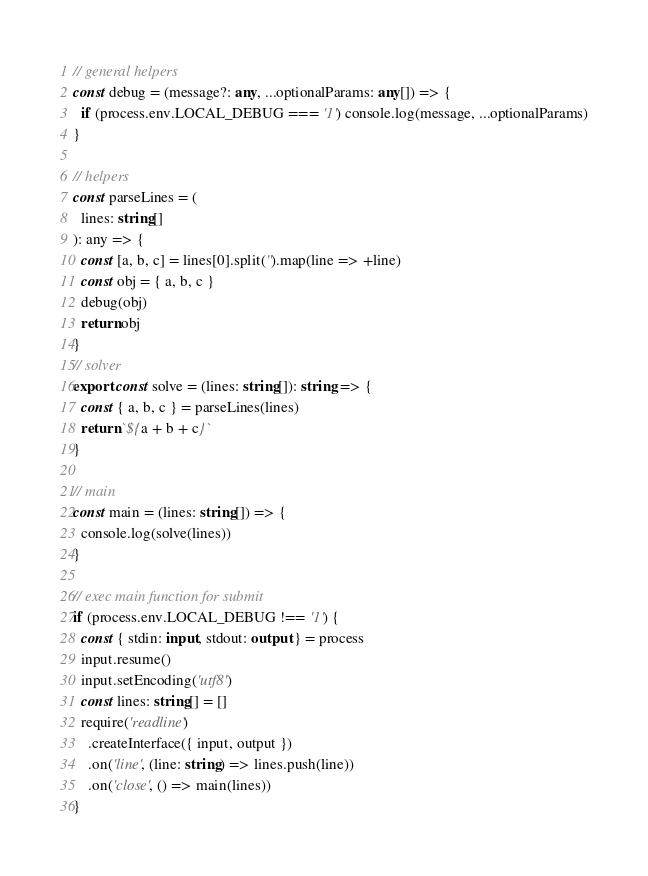Convert code to text. <code><loc_0><loc_0><loc_500><loc_500><_TypeScript_>// general helpers
const debug = (message?: any, ...optionalParams: any[]) => {
  if (process.env.LOCAL_DEBUG === '1') console.log(message, ...optionalParams)
}

// helpers
const parseLines = (
  lines: string[]
): any => {
  const [a, b, c] = lines[0].split('').map(line => +line)
  const obj = { a, b, c }
  debug(obj)
  return obj
}
// solver
export const solve = (lines: string[]): string => {
  const { a, b, c } = parseLines(lines)
  return `${a + b + c}`
}

// main
const main = (lines: string[]) => {
  console.log(solve(lines))
}

// exec main function for submit
if (process.env.LOCAL_DEBUG !== '1') {
  const { stdin: input, stdout: output } = process
  input.resume()
  input.setEncoding('utf8')
  const lines: string[] = []
  require('readline')
    .createInterface({ input, output })
    .on('line', (line: string) => lines.push(line))
    .on('close', () => main(lines))
}
</code> 